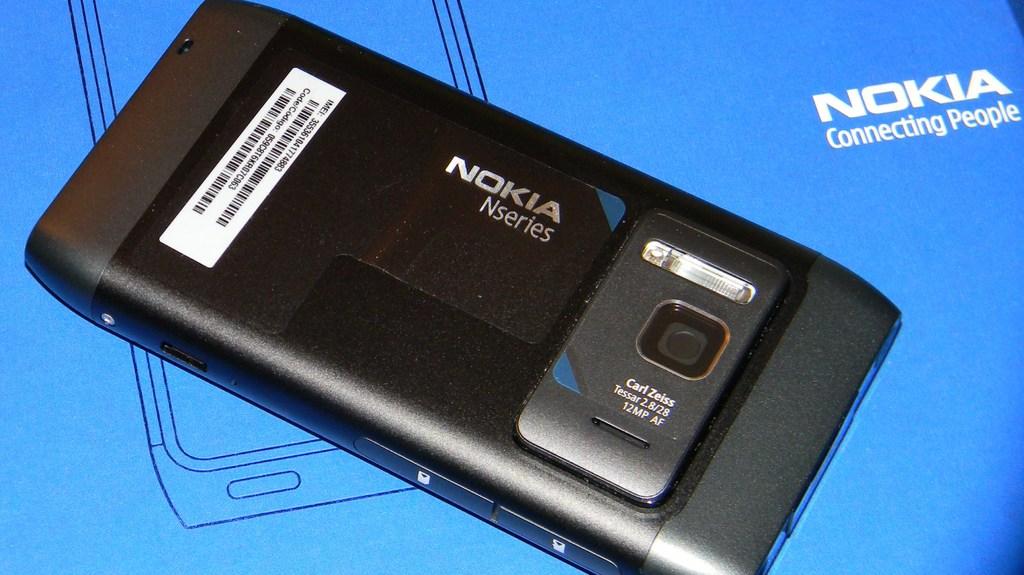What is the brand of this phone?
Ensure brevity in your answer.  Nokia. What is the model of the phone?
Your answer should be very brief. Nokia. 